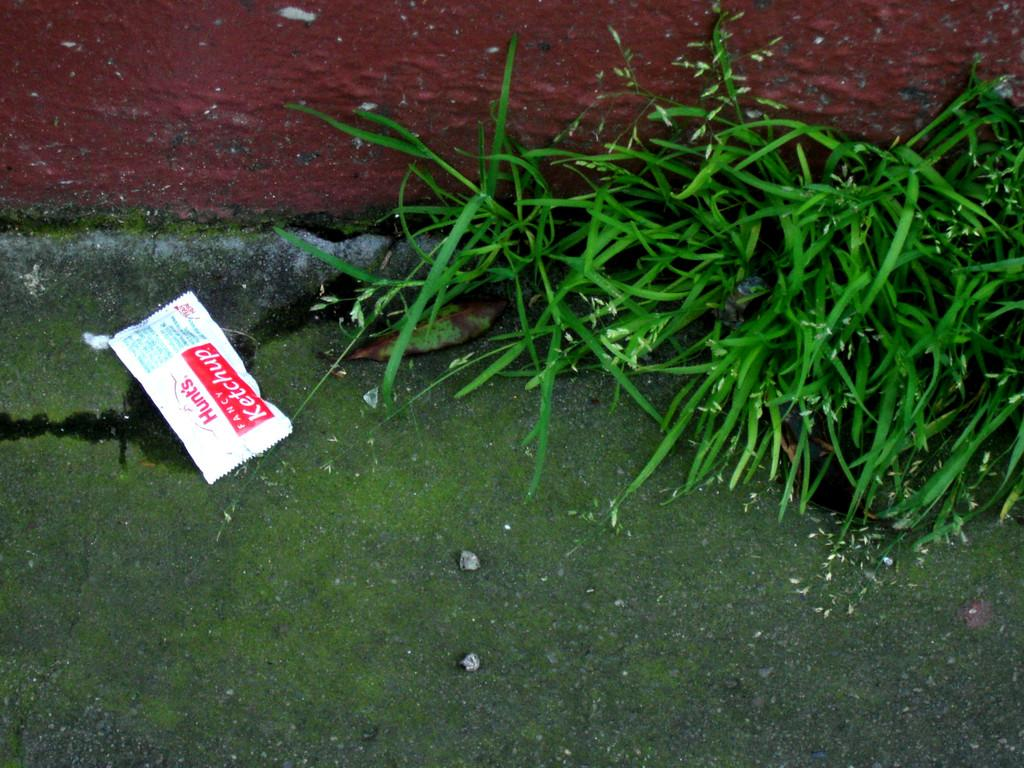What type of living organisms can be seen in the image? Plants can be seen in the image. What else is present in the image besides the plants? There is a packet in the image. What type of tax is being discussed in the image? There is no discussion of tax in the image; it features plants and a packet. What kind of door can be seen in the image? There is no door present in the image. 